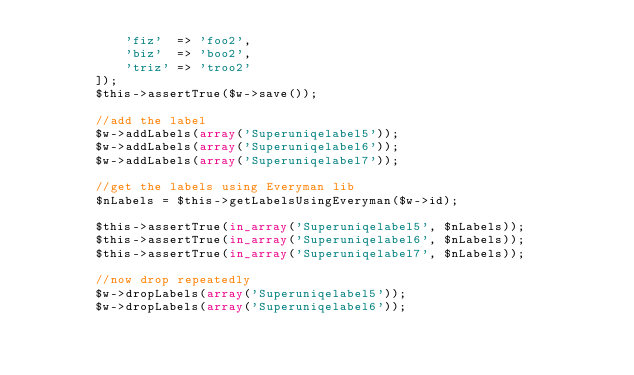<code> <loc_0><loc_0><loc_500><loc_500><_PHP_>            'fiz'  => 'foo2',
            'biz'  => 'boo2',
            'triz' => 'troo2'
        ]);
        $this->assertTrue($w->save());

        //add the label
        $w->addLabels(array('Superuniqelabel5'));
        $w->addLabels(array('Superuniqelabel6'));
        $w->addLabels(array('Superuniqelabel7'));

        //get the labels using Everyman lib
        $nLabels = $this->getLabelsUsingEveryman($w->id);

        $this->assertTrue(in_array('Superuniqelabel5', $nLabels));
        $this->assertTrue(in_array('Superuniqelabel6', $nLabels));
        $this->assertTrue(in_array('Superuniqelabel7', $nLabels));

        //now drop repeatedly
        $w->dropLabels(array('Superuniqelabel5'));
        $w->dropLabels(array('Superuniqelabel6'));</code> 